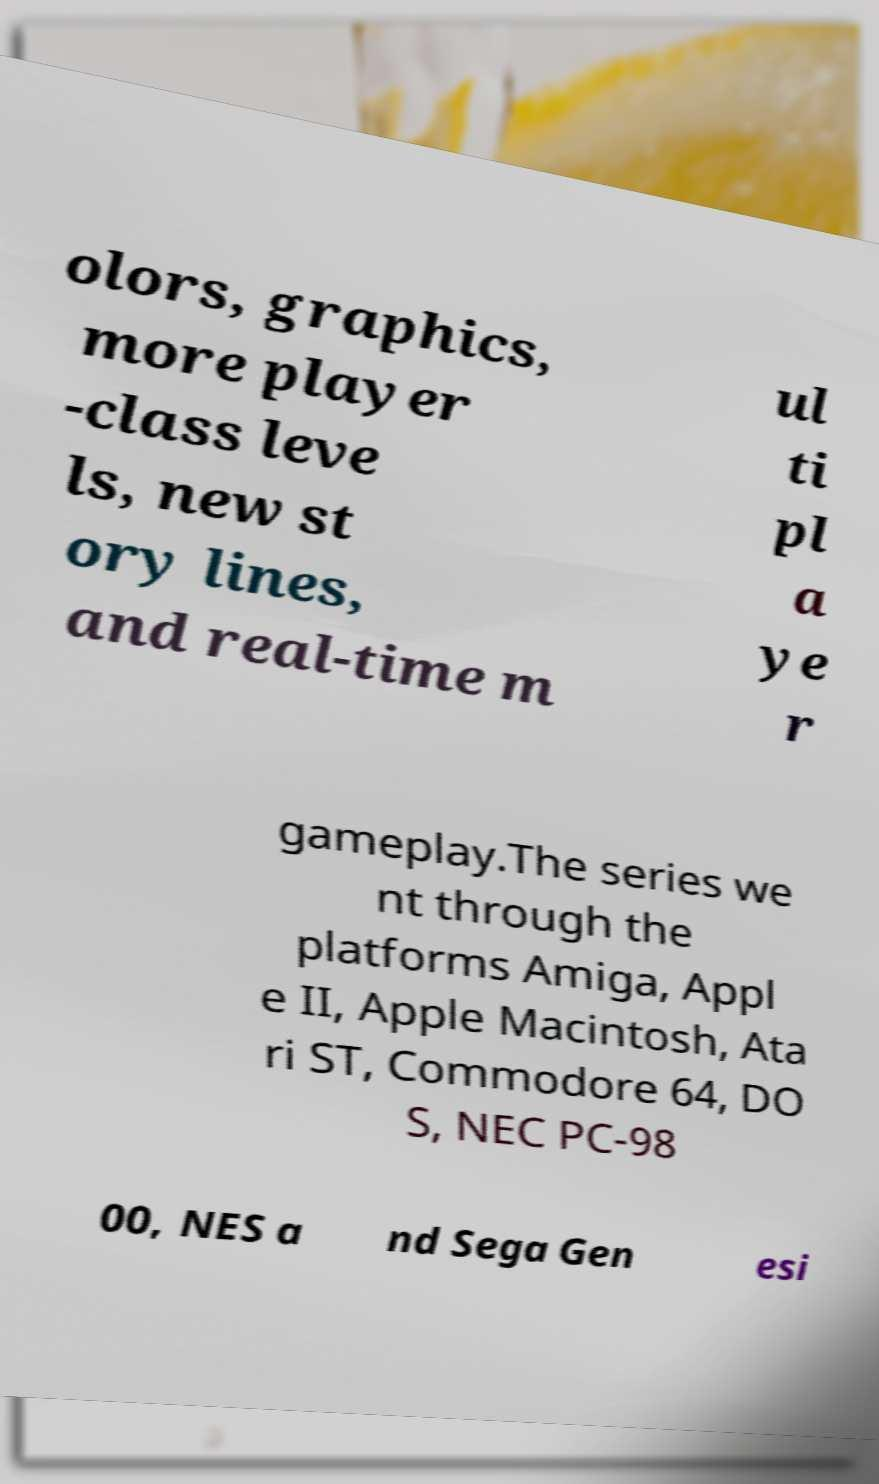What messages or text are displayed in this image? I need them in a readable, typed format. olors, graphics, more player -class leve ls, new st ory lines, and real-time m ul ti pl a ye r gameplay.The series we nt through the platforms Amiga, Appl e II, Apple Macintosh, Ata ri ST, Commodore 64, DO S, NEC PC-98 00, NES a nd Sega Gen esi 